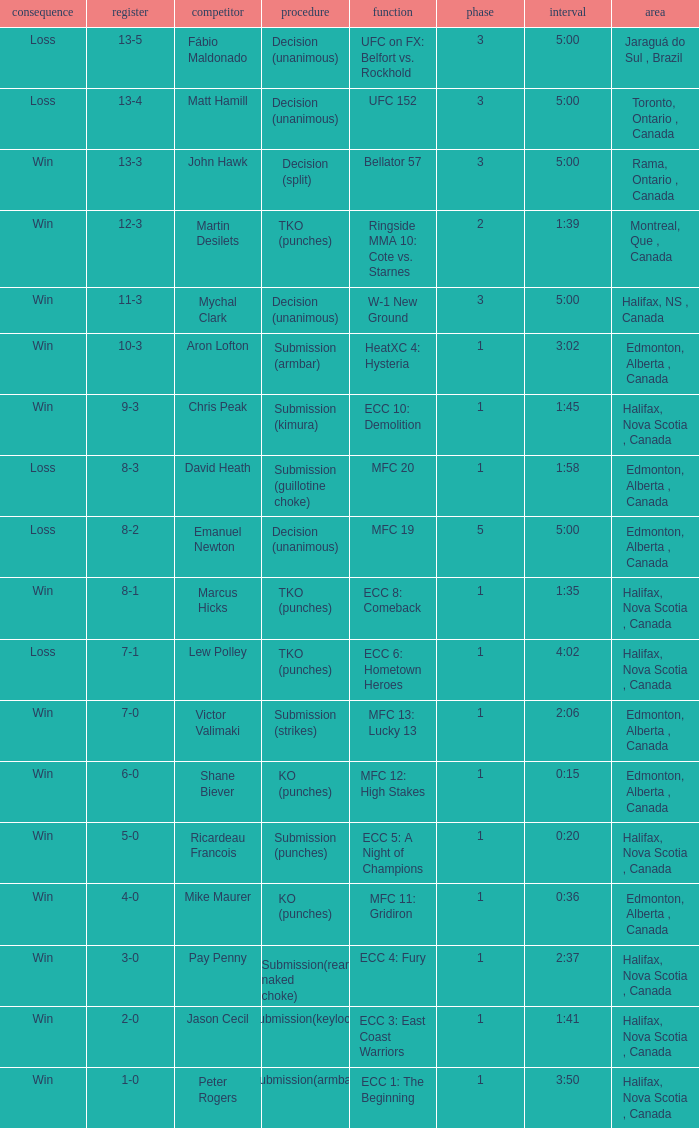What is the round of the match with Emanuel Newton as the opponent? 5.0. 